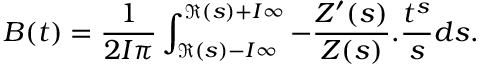<formula> <loc_0><loc_0><loc_500><loc_500>B ( t ) = \frac { 1 } { 2 I \pi } \int _ { \Re ( s ) - I \infty } ^ { \Re ( s ) + I \infty } - \frac { Z ^ { \prime } ( s ) } { Z ( s ) } . \frac { t ^ { s } } { s } d s .</formula> 